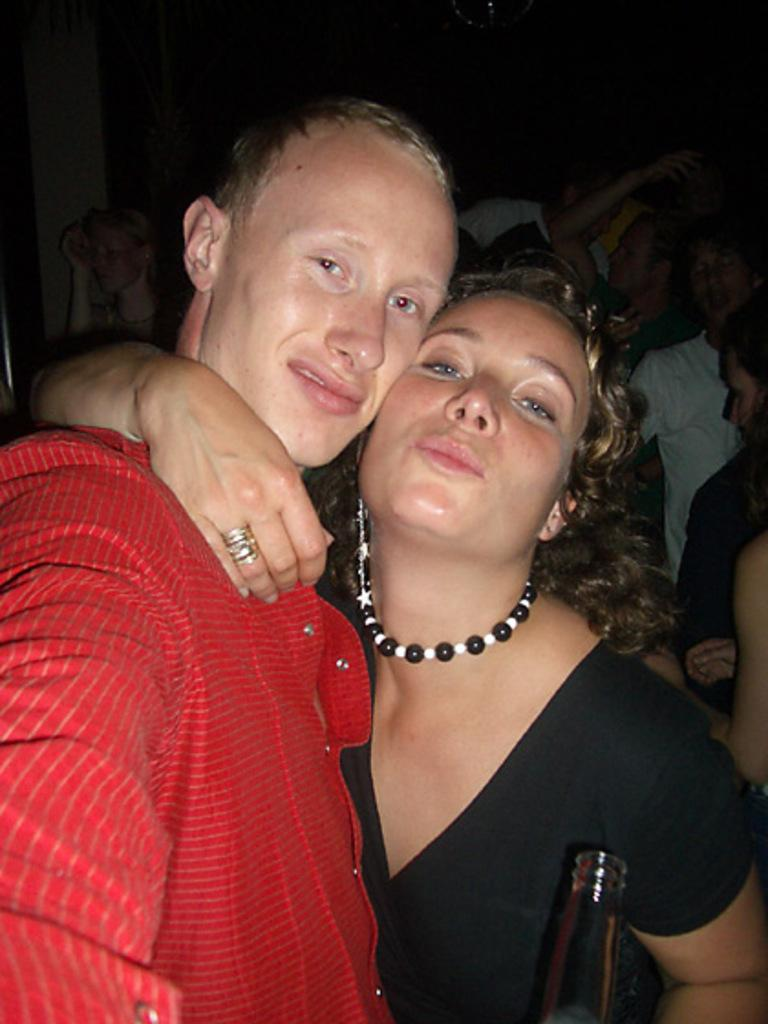What is the main subject of the image? The main subject of the image is a group of people. Can you describe any specific actions or objects held by the people in the image? One woman is holding a bottle in her hand. What type of activity is the committee engaged in during the selection process in the image? There is no committee, selection process, or activity mentioned in the image. The image only shows a group of people, with one woman holding a bottle. 